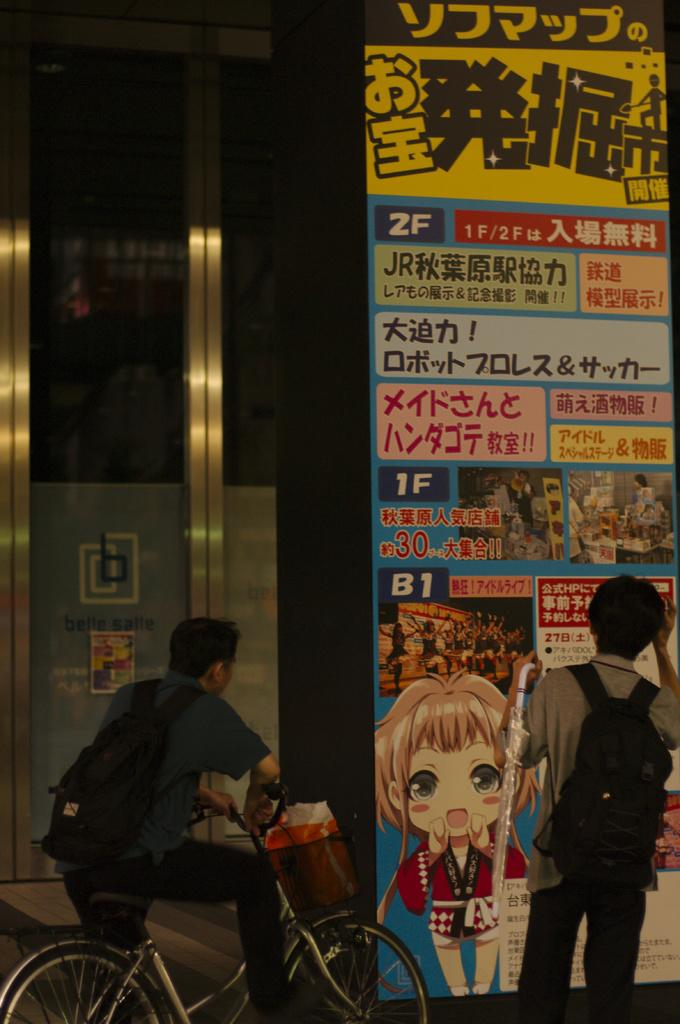What is the person standing on the floor doing? The person is holding an umbrella. What is the other person in the image doing? The other person is sitting on a bicycle. What can be seen on the wall in the image? There is a poster in the image. What is written on the poster? There is writing on the poster. How many children are sitting on the father's lap in the image? There is no father or children present in the image. What type of eggs are being used to make the omelet in the image? There is no omelet or eggs present in the image. 